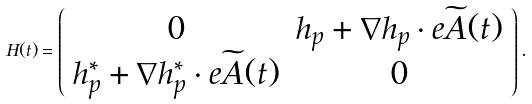<formula> <loc_0><loc_0><loc_500><loc_500>H ( t ) = \left ( \begin{array} { c c } 0 & h _ { p } + \nabla h _ { p } \cdot e \widetilde { A } ( t ) \\ h ^ { * } _ { p } + \nabla h ^ { * } _ { p } \cdot e \widetilde { A } ( t ) & 0 \end{array} \right ) .</formula> 